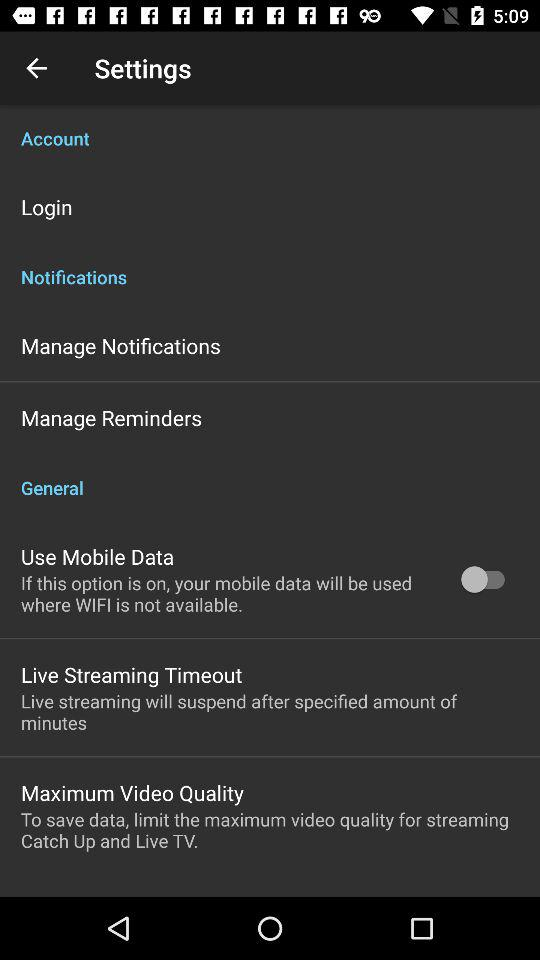How many items are in the notifications section?
Answer the question using a single word or phrase. 2 